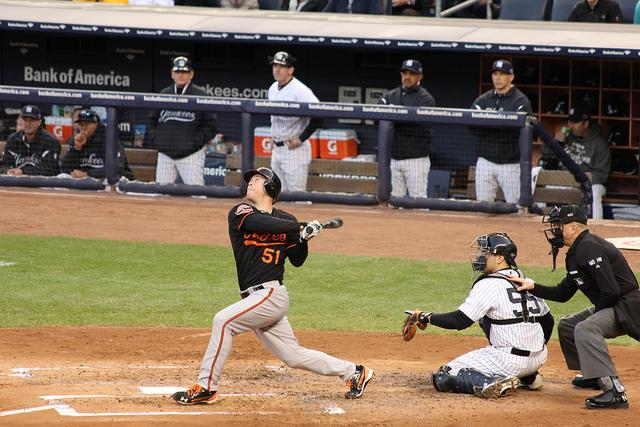What holds the beverages for the players in the dugout? Please explain your reasoning. coolers. The coolers have drinks. 